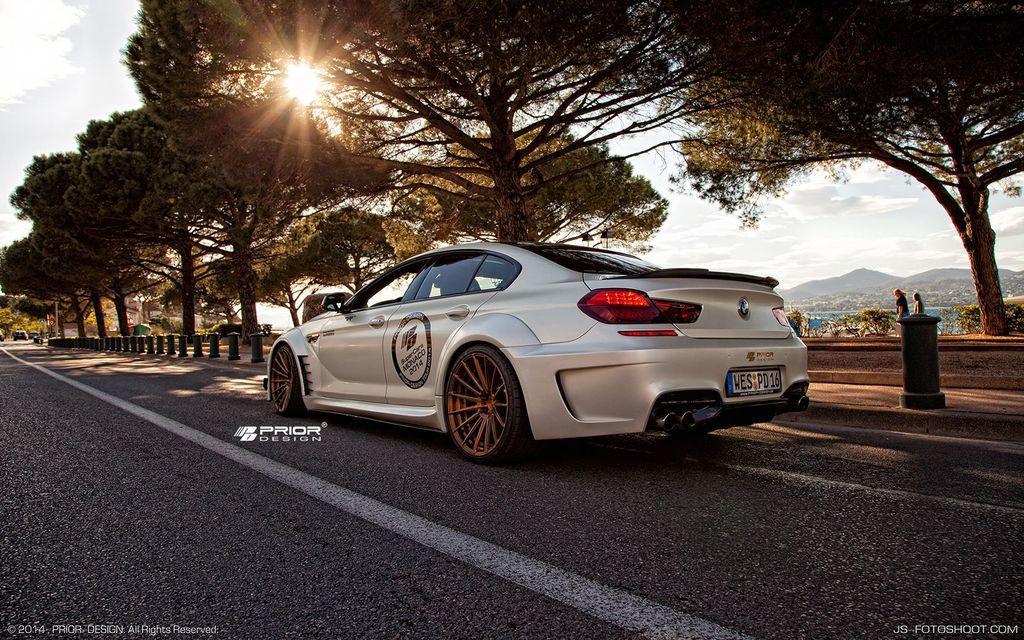Describe this image in one or two sentences. In this image we can see a car on the road. There are trees. There are safety poles. In the background of the image there is sky, mountain, people walking, sun. At the bottom of the image there is some text. 